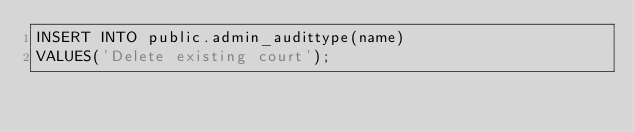Convert code to text. <code><loc_0><loc_0><loc_500><loc_500><_SQL_>INSERT INTO public.admin_audittype(name)
VALUES('Delete existing court');
</code> 